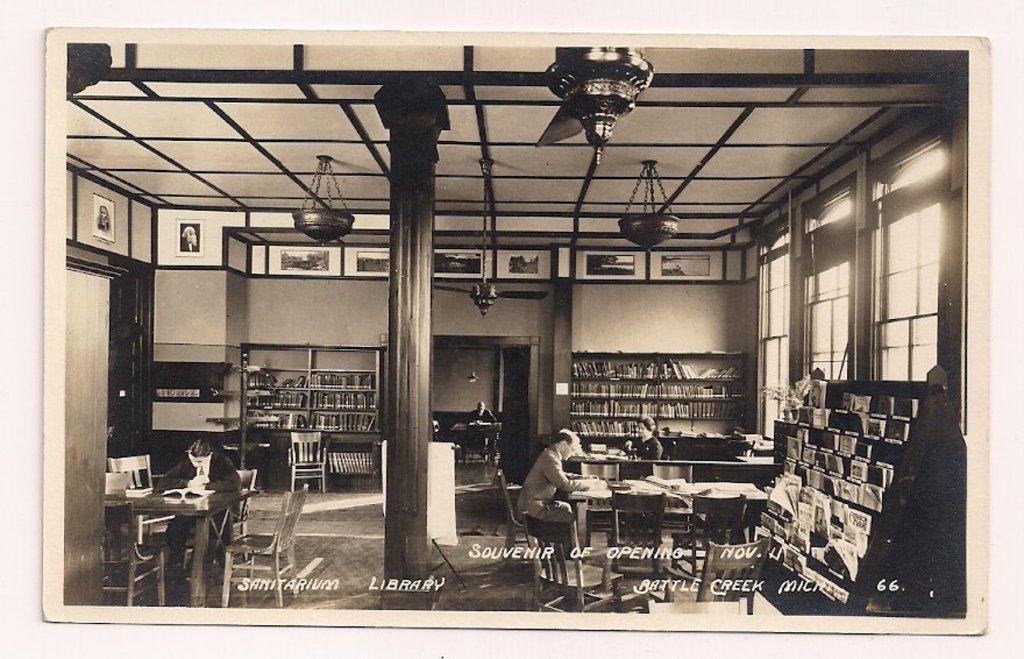Can you describe this image briefly? It is a black and white picture. Here we can see wall, ceiling with fan, pillars, chairs, tables, shelves with books, glass window and photo frames. Here we can see few people are sitting on the chairs. At the bottom, there is a floor and some text we can see. The borders of the image, we can see white color. 